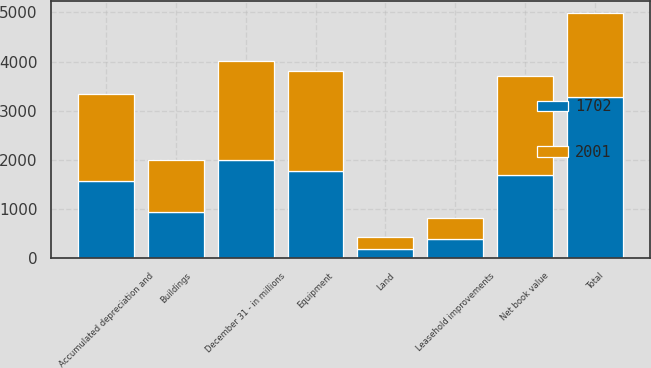Convert chart to OTSL. <chart><loc_0><loc_0><loc_500><loc_500><stacked_bar_chart><ecel><fcel>December 31 - in millions<fcel>Land<fcel>Buildings<fcel>Equipment<fcel>Leasehold improvements<fcel>Total<fcel>Accumulated depreciation and<fcel>Net book value<nl><fcel>2001<fcel>2007<fcel>250<fcel>1053<fcel>2029<fcel>433<fcel>1702<fcel>1764<fcel>2001<nl><fcel>1702<fcel>2006<fcel>187<fcel>937<fcel>1771<fcel>385<fcel>3280<fcel>1578<fcel>1702<nl></chart> 